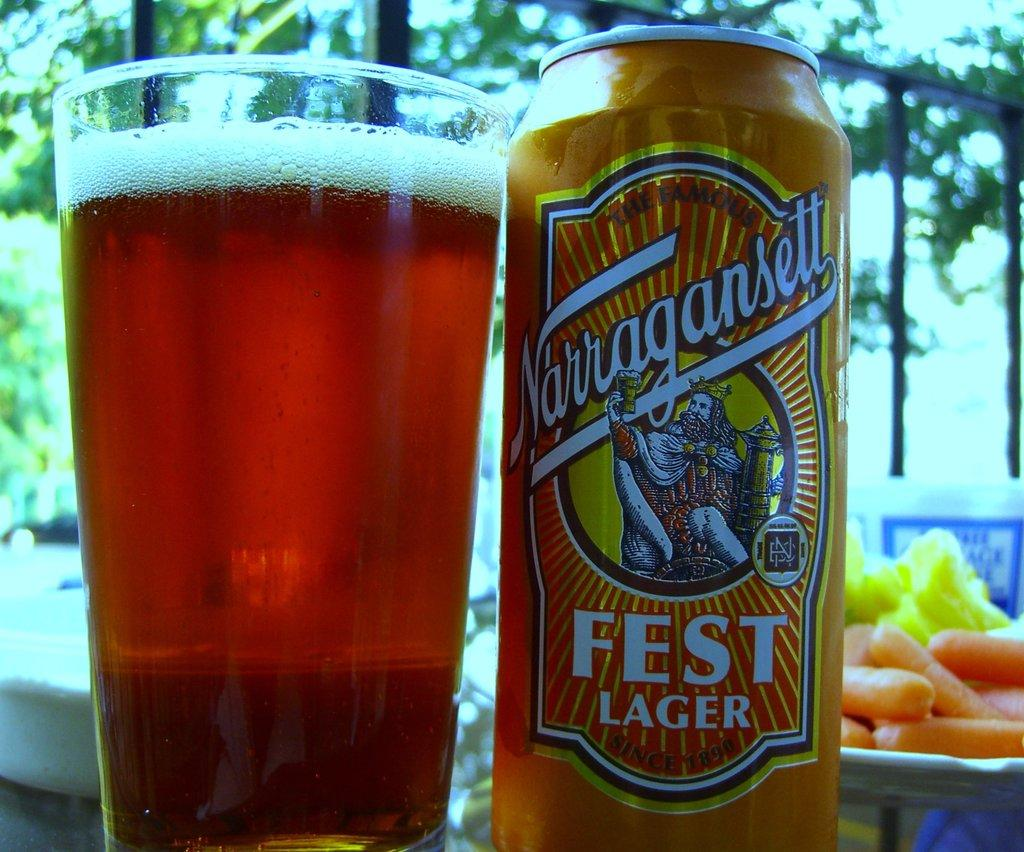<image>
Create a compact narrative representing the image presented. A can of Narragansett Fest Lager and a large glass filled with the lager. 